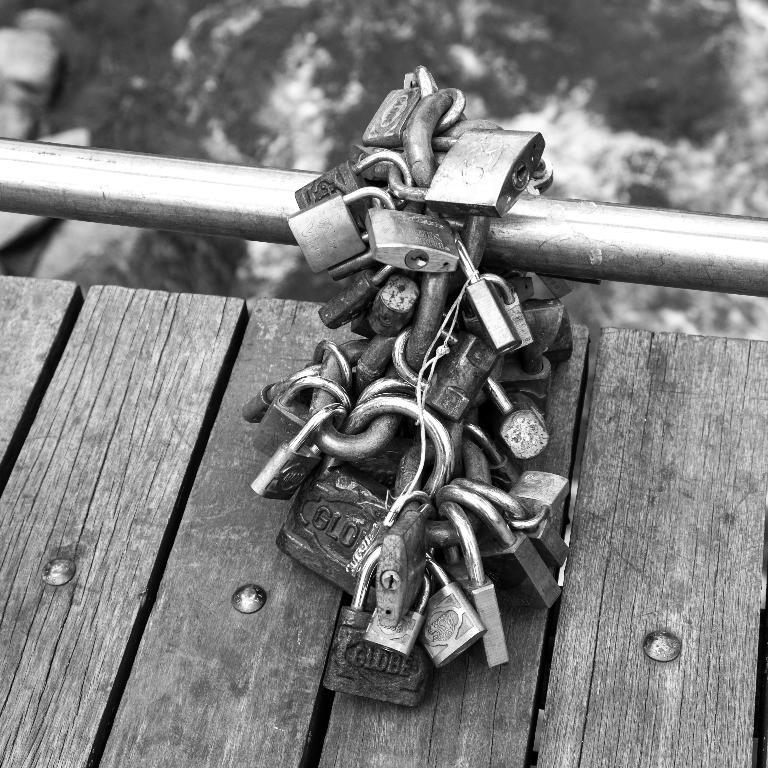What type of surface is visible in the image? There is a wooden surface in the image. What objects are related to security in the image? There are locks in the image. What long, thin object can be seen in the image? There is a rod in the image. What type of plane is flying over the wooden surface in the image? There is no plane visible in the image; it only features a wooden surface, locks, and a rod. 